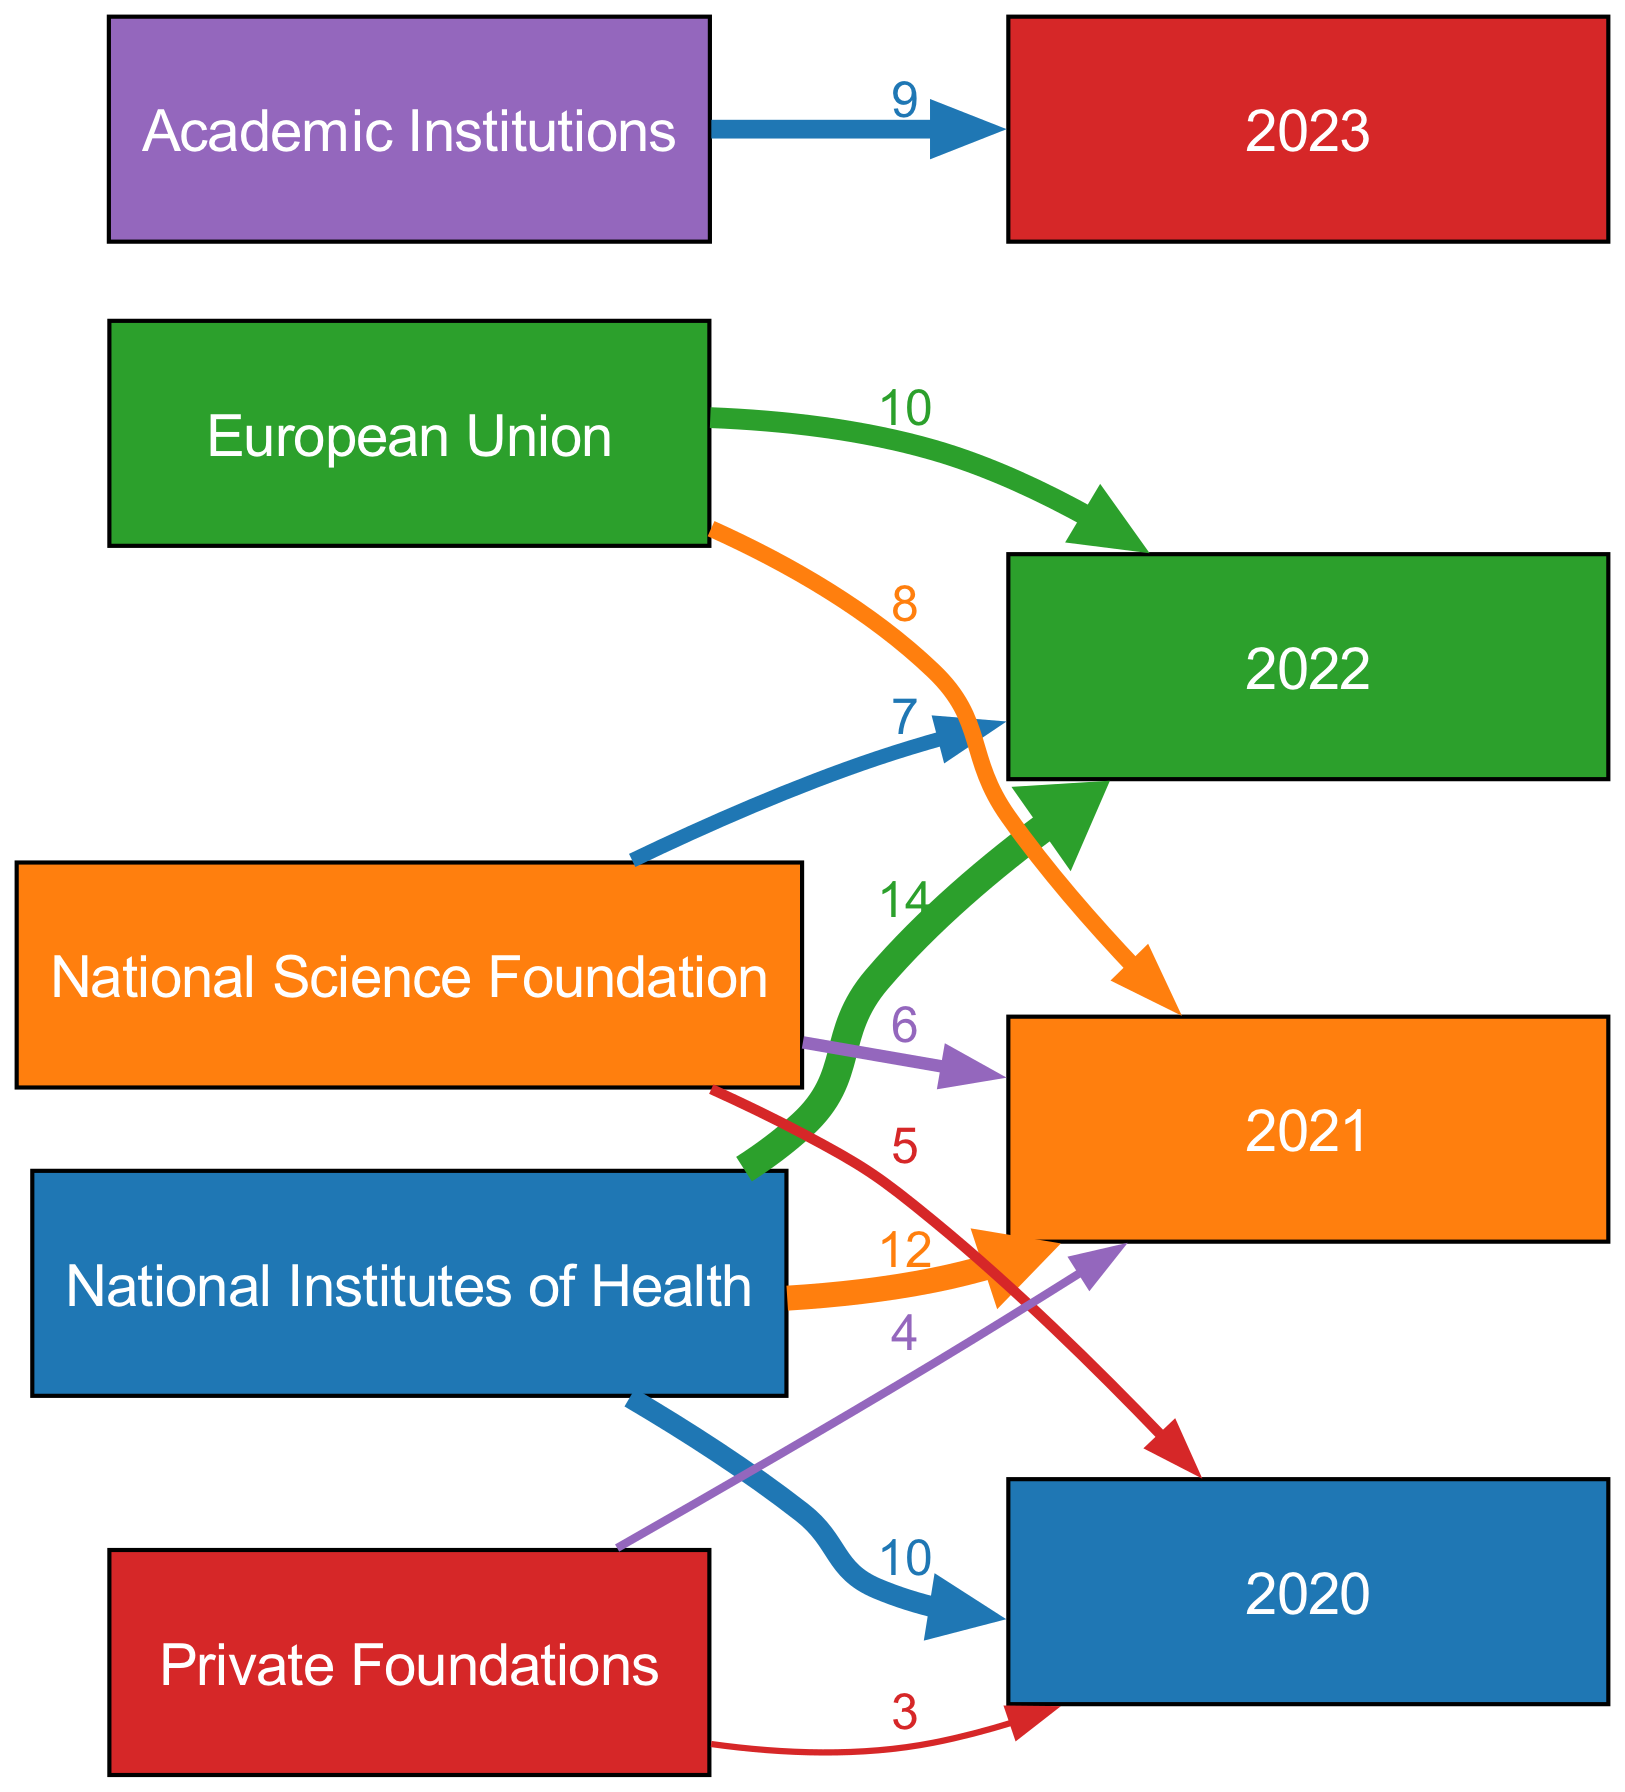What is the total grant amount from NIH in 2022? The diagram shows a link from the National Institutes of Health to the year 2022 with a value of 14. Thus, we can directly see that the total grant amount from NIH in 2022 is 14.
Answer: 14 How many sources of funding are represented in the diagram? The diagram features five distinct sources labeled: National Institutes of Health, National Science Foundation, European Union, Private Foundations, and Academic Institutions. Counting these gives us a total of five sources.
Answer: 5 Which funding source contributed the least in 2020? By examining the values for 2020, the contributions from NIH, NSF, and Private Foundations are 10, 5, and 3, respectively. The smallest number here is from Private Foundations, which contributed 3.
Answer: Private Foundations What is the total funding amount received from NSF over all years displayed? To find the total funding from the National Science Foundation, we add the individual contributions from the years 2020, 2021, and 2022, which are 5, 6, and 7. Summing these yields 5 + 6 + 7 = 18.
Answer: 18 What is the most recent year shown in the diagram for academic institution funding? The diagram displays a link from Academic Institutions to the year 2023, indicating this is the most recent year represented for funding from this source.
Answer: 2023 Which funding source had the highest total contribution in 2021? In 2021, NIH contributed 12, NSF contributed 6, and the EU contributed 8. Evaluating these, NIH's contribution of 12 is the highest among the three sources listed for 2021.
Answer: NIH Which year saw the highest funding total from all sources combined? By adding up the values for each year: 2020 (10+5+3), 2021 (12+6+8), 2022 (14+7+10), and 2023 (9). The sums are 18, 26, 31, and 9, respectively. The highest total is 31 in 2022.
Answer: 2022 Is there any funding contribution from the European Union in 2020? The diagram does not show any link from the European Union to the year 2020, indicating a contribution level of zero from the EU for that year.
Answer: No 